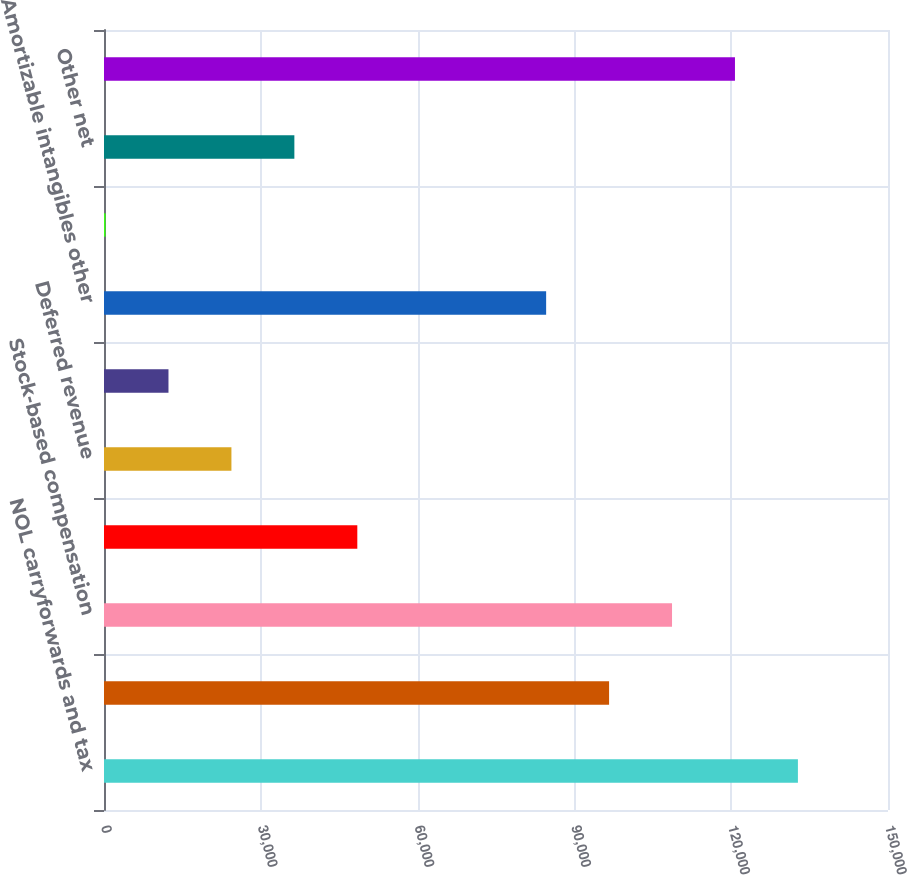<chart> <loc_0><loc_0><loc_500><loc_500><bar_chart><fcel>NOL carryforwards and tax<fcel>Foreign NOL carryforwards<fcel>Stock-based compensation<fcel>Nondeductible reserves and<fcel>Deferred revenue<fcel>Depreciation<fcel>Amortizable intangibles other<fcel>Change in unrealized losses on<fcel>Other net<fcel>Capitalized research and<nl><fcel>132764<fcel>96635.6<fcel>108678<fcel>48464.8<fcel>24379.4<fcel>12336.7<fcel>84592.9<fcel>294<fcel>36422.1<fcel>120721<nl></chart> 